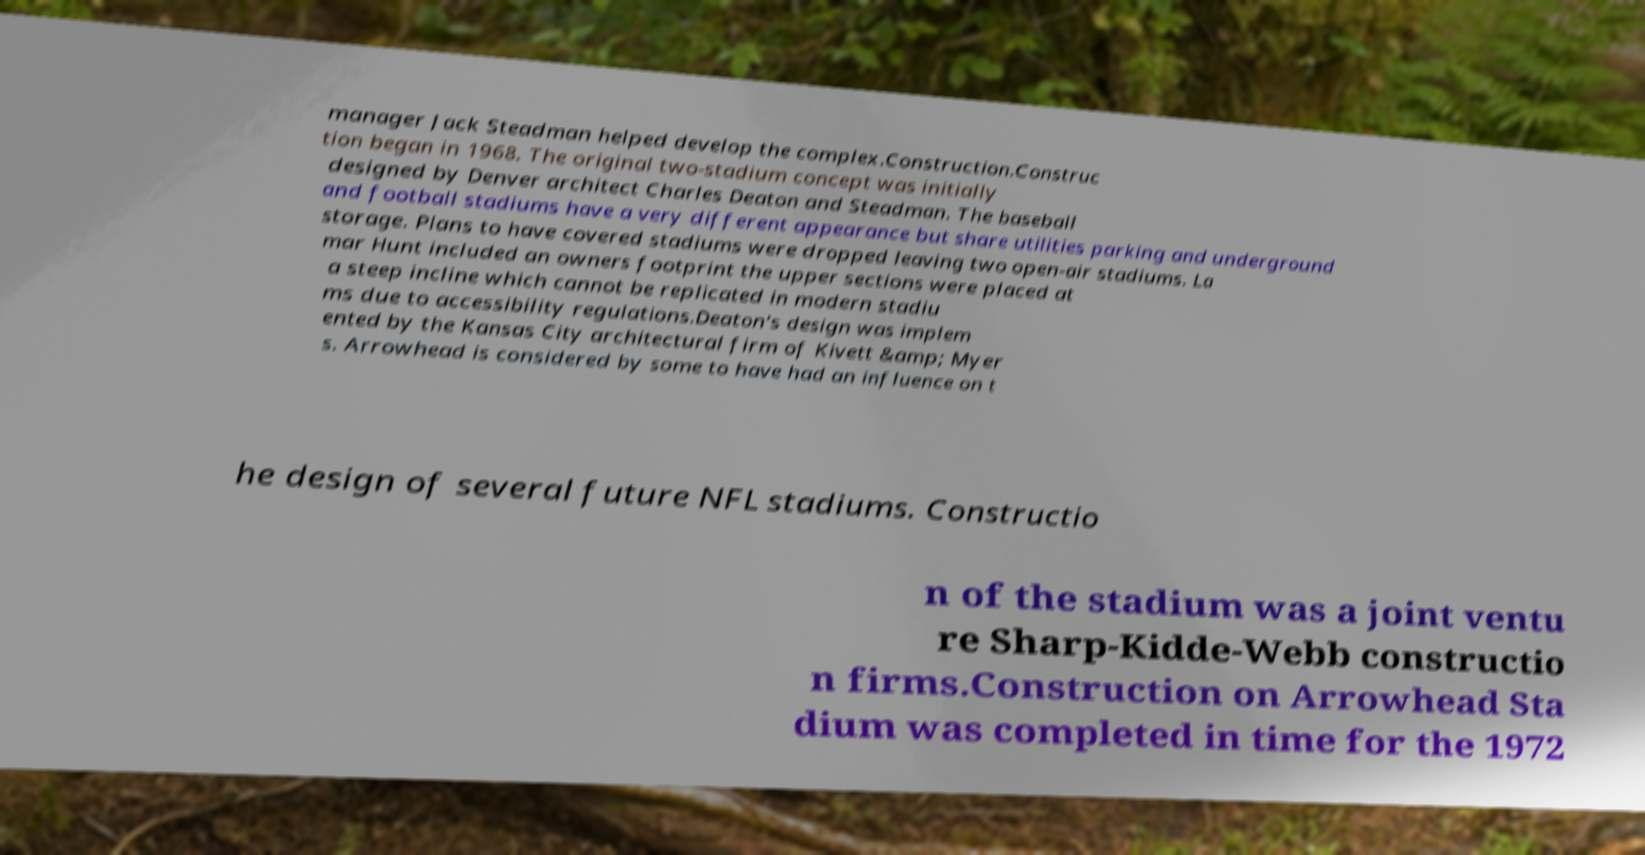Can you read and provide the text displayed in the image?This photo seems to have some interesting text. Can you extract and type it out for me? manager Jack Steadman helped develop the complex.Construction.Construc tion began in 1968. The original two-stadium concept was initially designed by Denver architect Charles Deaton and Steadman. The baseball and football stadiums have a very different appearance but share utilities parking and underground storage. Plans to have covered stadiums were dropped leaving two open-air stadiums. La mar Hunt included an owners footprint the upper sections were placed at a steep incline which cannot be replicated in modern stadiu ms due to accessibility regulations.Deaton's design was implem ented by the Kansas City architectural firm of Kivett &amp; Myer s. Arrowhead is considered by some to have had an influence on t he design of several future NFL stadiums. Constructio n of the stadium was a joint ventu re Sharp-Kidde-Webb constructio n firms.Construction on Arrowhead Sta dium was completed in time for the 1972 